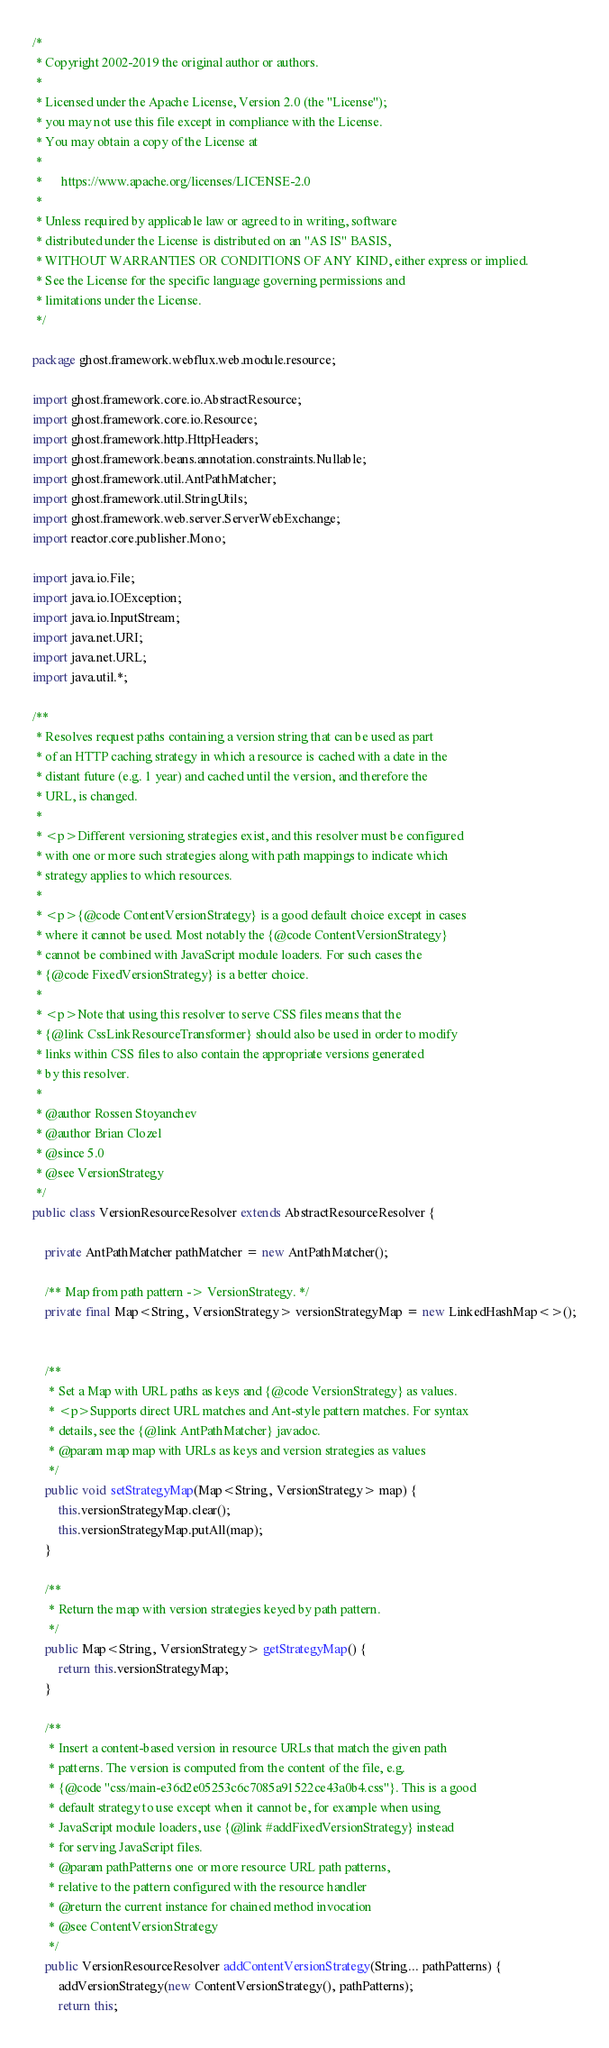Convert code to text. <code><loc_0><loc_0><loc_500><loc_500><_Java_>/*
 * Copyright 2002-2019 the original author or authors.
 *
 * Licensed under the Apache License, Version 2.0 (the "License");
 * you may not use this file except in compliance with the License.
 * You may obtain a copy of the License at
 *
 *      https://www.apache.org/licenses/LICENSE-2.0
 *
 * Unless required by applicable law or agreed to in writing, software
 * distributed under the License is distributed on an "AS IS" BASIS,
 * WITHOUT WARRANTIES OR CONDITIONS OF ANY KIND, either express or implied.
 * See the License for the specific language governing permissions and
 * limitations under the License.
 */

package ghost.framework.webflux.web.module.resource;

import ghost.framework.core.io.AbstractResource;
import ghost.framework.core.io.Resource;
import ghost.framework.http.HttpHeaders;
import ghost.framework.beans.annotation.constraints.Nullable;
import ghost.framework.util.AntPathMatcher;
import ghost.framework.util.StringUtils;
import ghost.framework.web.server.ServerWebExchange;
import reactor.core.publisher.Mono;

import java.io.File;
import java.io.IOException;
import java.io.InputStream;
import java.net.URI;
import java.net.URL;
import java.util.*;

/**
 * Resolves request paths containing a version string that can be used as part
 * of an HTTP caching strategy in which a resource is cached with a date in the
 * distant future (e.g. 1 year) and cached until the version, and therefore the
 * URL, is changed.
 *
 * <p>Different versioning strategies exist, and this resolver must be configured
 * with one or more such strategies along with path mappings to indicate which
 * strategy applies to which resources.
 *
 * <p>{@code ContentVersionStrategy} is a good default choice except in cases
 * where it cannot be used. Most notably the {@code ContentVersionStrategy}
 * cannot be combined with JavaScript module loaders. For such cases the
 * {@code FixedVersionStrategy} is a better choice.
 *
 * <p>Note that using this resolver to serve CSS files means that the
 * {@link CssLinkResourceTransformer} should also be used in order to modify
 * links within CSS files to also contain the appropriate versions generated
 * by this resolver.
 *
 * @author Rossen Stoyanchev
 * @author Brian Clozel
 * @since 5.0
 * @see VersionStrategy
 */
public class VersionResourceResolver extends AbstractResourceResolver {

	private AntPathMatcher pathMatcher = new AntPathMatcher();

	/** Map from path pattern -> VersionStrategy. */
	private final Map<String, VersionStrategy> versionStrategyMap = new LinkedHashMap<>();


	/**
	 * Set a Map with URL paths as keys and {@code VersionStrategy} as values.
	 * <p>Supports direct URL matches and Ant-style pattern matches. For syntax
	 * details, see the {@link AntPathMatcher} javadoc.
	 * @param map map with URLs as keys and version strategies as values
	 */
	public void setStrategyMap(Map<String, VersionStrategy> map) {
		this.versionStrategyMap.clear();
		this.versionStrategyMap.putAll(map);
	}

	/**
	 * Return the map with version strategies keyed by path pattern.
	 */
	public Map<String, VersionStrategy> getStrategyMap() {
		return this.versionStrategyMap;
	}

	/**
	 * Insert a content-based version in resource URLs that match the given path
	 * patterns. The version is computed from the content of the file, e.g.
	 * {@code "css/main-e36d2e05253c6c7085a91522ce43a0b4.css"}. This is a good
	 * default strategy to use except when it cannot be, for example when using
	 * JavaScript module loaders, use {@link #addFixedVersionStrategy} instead
	 * for serving JavaScript files.
	 * @param pathPatterns one or more resource URL path patterns,
	 * relative to the pattern configured with the resource handler
	 * @return the current instance for chained method invocation
	 * @see ContentVersionStrategy
	 */
	public VersionResourceResolver addContentVersionStrategy(String... pathPatterns) {
		addVersionStrategy(new ContentVersionStrategy(), pathPatterns);
		return this;</code> 